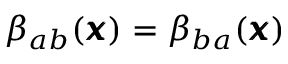Convert formula to latex. <formula><loc_0><loc_0><loc_500><loc_500>{ \beta } _ { a b } ( { \pm b x } ) = { \beta } _ { b a } ( { \pm b x } )</formula> 